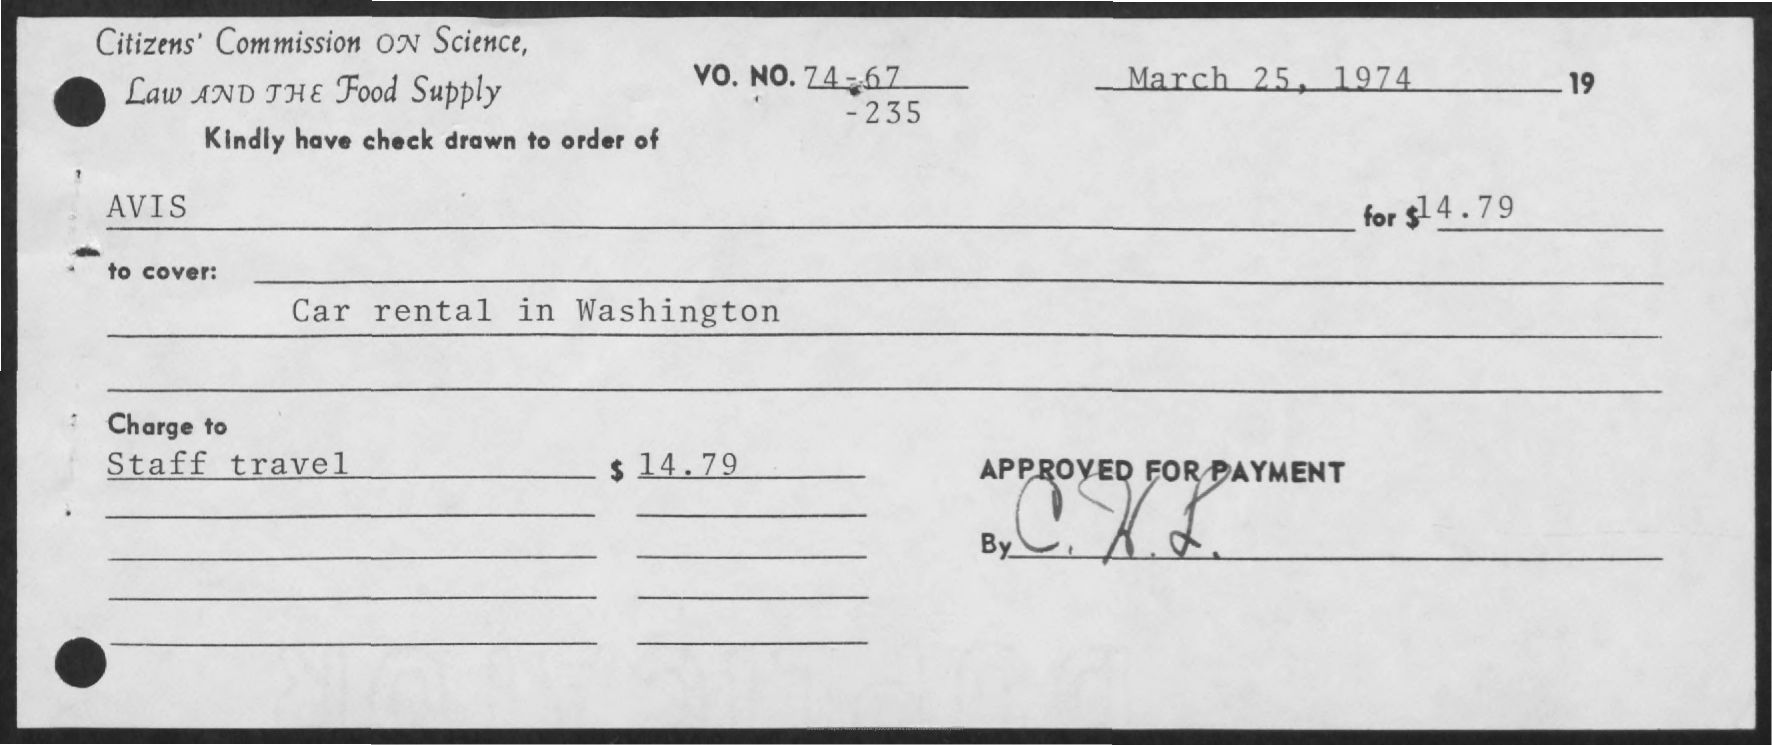Highlight a few significant elements in this photo. The document indicates that the date is March 25, 1974. The amount is $14.79. The "Charge to" for staff travel is $14.79. The check is made out to the person named AVIS. 